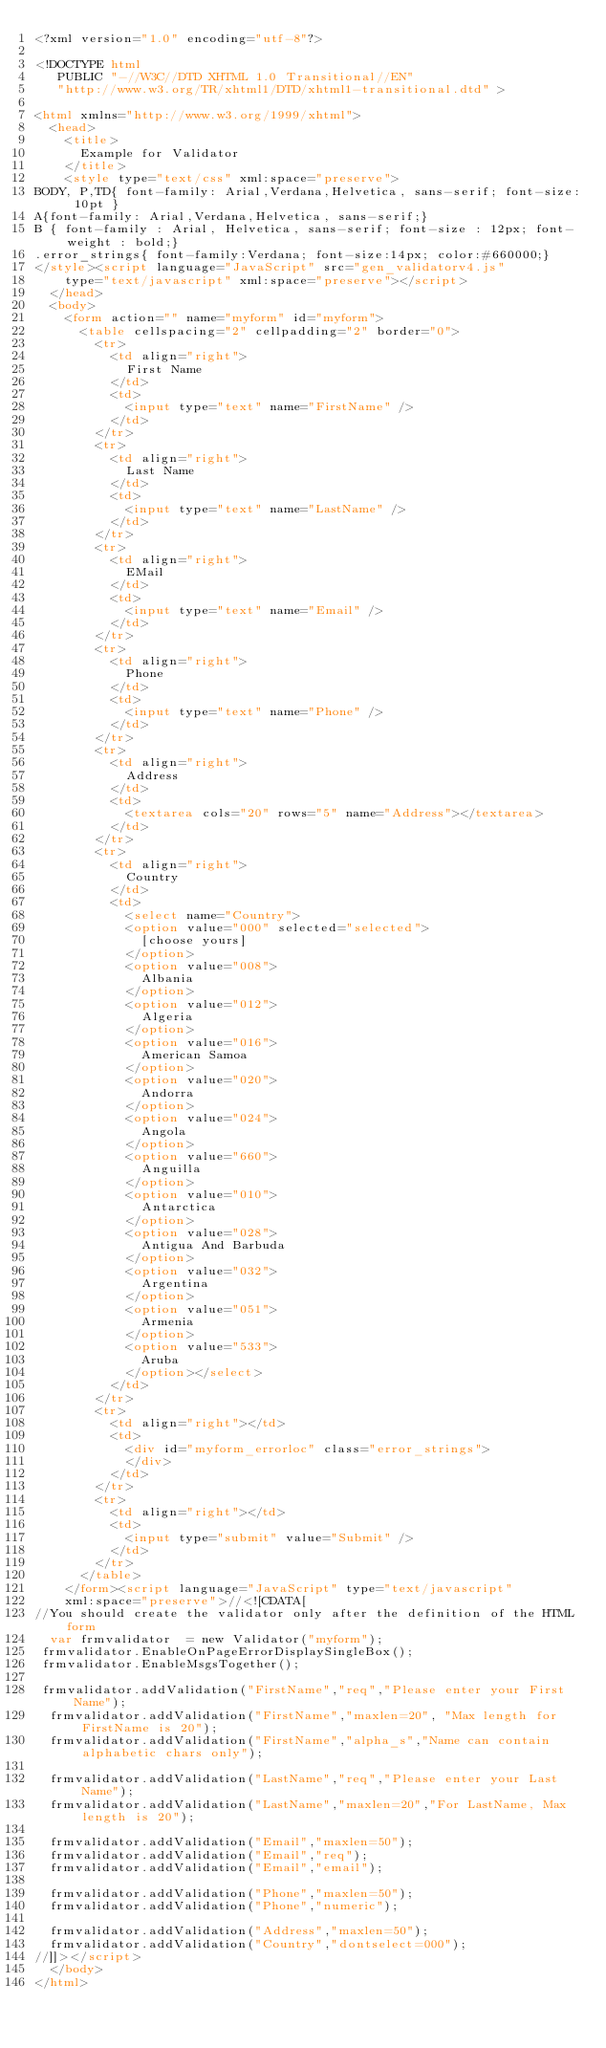Convert code to text. <code><loc_0><loc_0><loc_500><loc_500><_HTML_><?xml version="1.0" encoding="utf-8"?>

<!DOCTYPE html
   PUBLIC "-//W3C//DTD XHTML 1.0 Transitional//EN"
   "http://www.w3.org/TR/xhtml1/DTD/xhtml1-transitional.dtd" >

<html xmlns="http://www.w3.org/1999/xhtml">
  <head>
    <title>
      Example for Validator
    </title>
    <style type="text/css" xml:space="preserve">
BODY, P,TD{ font-family: Arial,Verdana,Helvetica, sans-serif; font-size: 10pt }
A{font-family: Arial,Verdana,Helvetica, sans-serif;}
B {	font-family : Arial, Helvetica, sans-serif;	font-size : 12px;	font-weight : bold;}
.error_strings{ font-family:Verdana; font-size:14px; color:#660000;}
</style><script language="JavaScript" src="gen_validatorv4.js"
    type="text/javascript" xml:space="preserve"></script>
  </head>
  <body>
    <form action="" name="myform" id="myform">
      <table cellspacing="2" cellpadding="2" border="0">
        <tr>
          <td align="right">
            First Name
          </td>
          <td>
            <input type="text" name="FirstName" />
          </td>
        </tr>
        <tr>
          <td align="right">
            Last Name
          </td>
          <td>
            <input type="text" name="LastName" />
          </td>
        </tr>
        <tr>
          <td align="right">
            EMail
          </td>
          <td>
            <input type="text" name="Email" />
          </td>
        </tr>
        <tr>
          <td align="right">
            Phone
          </td>
          <td>
            <input type="text" name="Phone" />
          </td>
        </tr>
        <tr>
          <td align="right">
            Address
          </td>
          <td>
            <textarea cols="20" rows="5" name="Address"></textarea>
          </td>
        </tr>
        <tr>
          <td align="right">
            Country
          </td>
          <td>
            <select name="Country">
            <option value="000" selected="selected">
              [choose yours]
            </option>
            <option value="008">
              Albania
            </option>
            <option value="012">
              Algeria
            </option>
            <option value="016">
              American Samoa
            </option>
            <option value="020">
              Andorra
            </option>
            <option value="024">
              Angola
            </option>
            <option value="660">
              Anguilla
            </option>
            <option value="010">
              Antarctica
            </option>
            <option value="028">
              Antigua And Barbuda
            </option>
            <option value="032">
              Argentina
            </option>
            <option value="051">
              Armenia
            </option>
            <option value="533">
              Aruba
            </option></select>
          </td>
        </tr>
        <tr>
          <td align="right"></td>
          <td>
            <div id="myform_errorloc" class="error_strings">
            </div>
          </td>
        </tr>
        <tr>
          <td align="right"></td>
          <td>
            <input type="submit" value="Submit" />
          </td>
        </tr>
      </table>
    </form><script language="JavaScript" type="text/javascript"
    xml:space="preserve">//<![CDATA[
//You should create the validator only after the definition of the HTML form
  var frmvalidator  = new Validator("myform");
 frmvalidator.EnableOnPageErrorDisplaySingleBox();
 frmvalidator.EnableMsgsTogether();
 
 frmvalidator.addValidation("FirstName","req","Please enter your First Name");
  frmvalidator.addValidation("FirstName","maxlen=20",	"Max length for FirstName is 20");
  frmvalidator.addValidation("FirstName","alpha_s","Name can contain alphabetic chars only");
  
  frmvalidator.addValidation("LastName","req","Please enter your Last Name");
  frmvalidator.addValidation("LastName","maxlen=20","For LastName, Max length is 20");
  
  frmvalidator.addValidation("Email","maxlen=50");
  frmvalidator.addValidation("Email","req");
  frmvalidator.addValidation("Email","email");
  
  frmvalidator.addValidation("Phone","maxlen=50");
  frmvalidator.addValidation("Phone","numeric");
  
  frmvalidator.addValidation("Address","maxlen=50");
  frmvalidator.addValidation("Country","dontselect=000");
//]]></script>
  </body>
</html>
</code> 